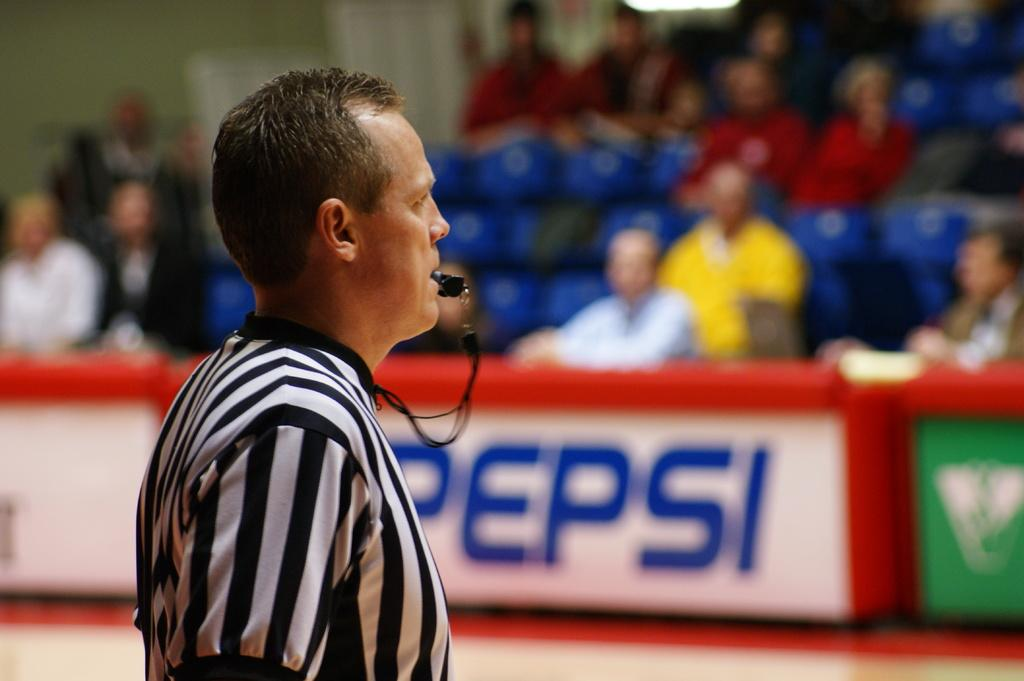Who is present in the image? There is a man in the image. What is the man doing in the image? The man is standing in the image. What object can be seen in the man's mouth? The man has a whistle in his mouth. What can be seen in the background of the image? There is a fence in the image. What are some people doing in the image? There are people sitting on chairs in the image. Can you see any shoes floating in the ocean in the image? There is no ocean or shoes visible in the image. 